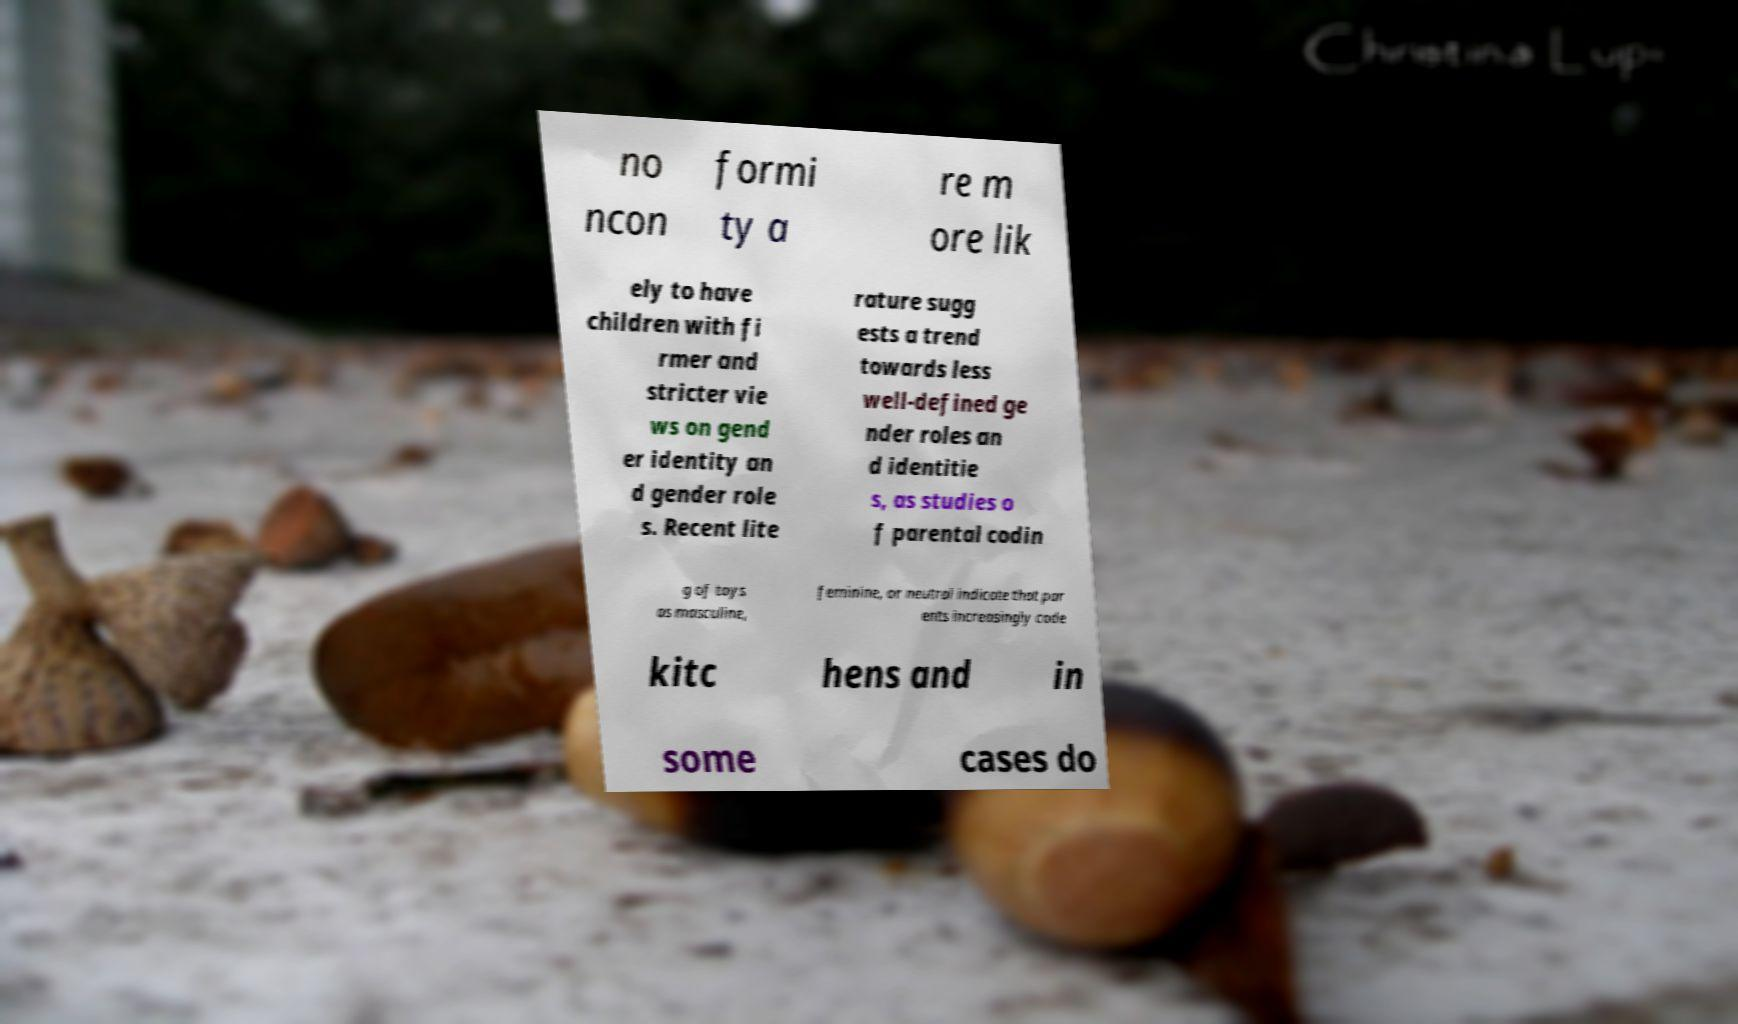I need the written content from this picture converted into text. Can you do that? no ncon formi ty a re m ore lik ely to have children with fi rmer and stricter vie ws on gend er identity an d gender role s. Recent lite rature sugg ests a trend towards less well-defined ge nder roles an d identitie s, as studies o f parental codin g of toys as masculine, feminine, or neutral indicate that par ents increasingly code kitc hens and in some cases do 